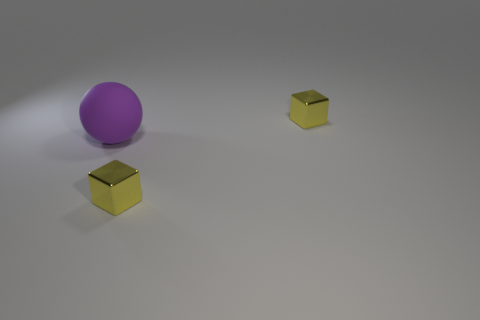Is there anything else that has the same material as the purple ball? While the image shows a purple ball and two gold-colored cubes, it's not possible to determine with absolute certainty if the materials are the same just from visual inspection. However, the surface of the cubes appears to be reflective, much like the ball, suggesting they could be made of a similar shiny material. Nonetheless, to confirm the exact material, we would require more information or a closer examination. 